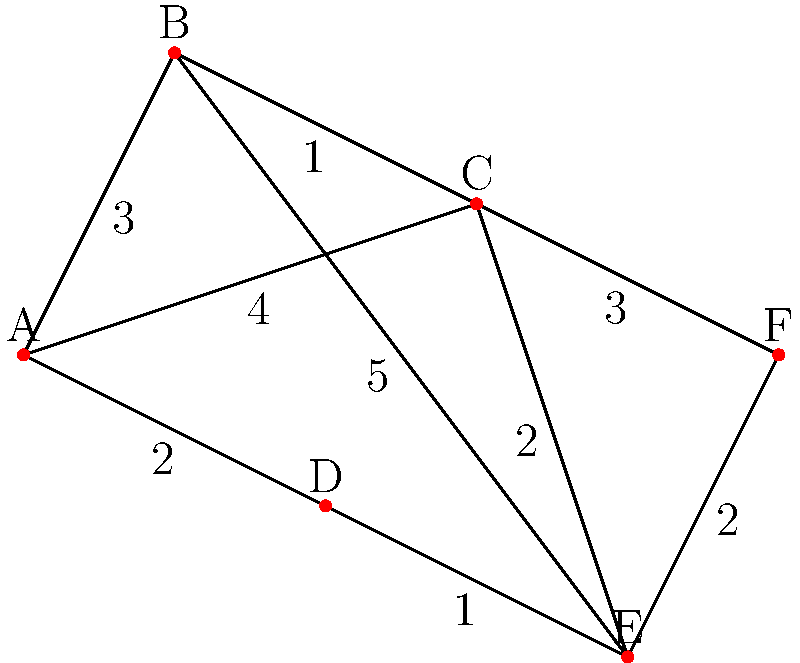In a network of innovative startups and their funding connections, you need to find the shortest path between startup A (a promising AI company) and startup F (a groundbreaking clean energy firm) to facilitate a potential collaboration. The edges represent the strength of connections between startups, with lower numbers indicating stronger ties. What is the length of the shortest path between A and F? To find the shortest path between A and F, we'll use Dijkstra's algorithm:

1. Initialize:
   - Distance to A: 0
   - Distance to all other nodes: infinity
   - Set of unvisited nodes: {A, B, C, D, E, F}

2. From A, we can reach:
   - B with distance 3
   - C with distance 4
   - D with distance 2
   Update distances: A(0), B(3), C(4), D(2), E(∞), F(∞)

3. Select node D (smallest distance)
   From D, we can reach E with total distance 2 + 1 = 3
   Update distances: A(0), B(3), C(4), D(2), E(3), F(∞)

4. Select node B (next smallest distance)
   From B, we can reach:
   - C with total distance 3 + 1 = 4 (no update needed)
   - E with total distance 3 + 5 = 8 (no update needed)

5. Select node E (next smallest distance)
   From E, we can reach F with total distance 3 + 2 = 5
   Update distances: A(0), B(3), C(4), D(2), E(3), F(5)

6. The algorithm terminates as we've reached F.

The shortest path from A to F is A -> D -> E -> F with a total length of 5.
Answer: 5 